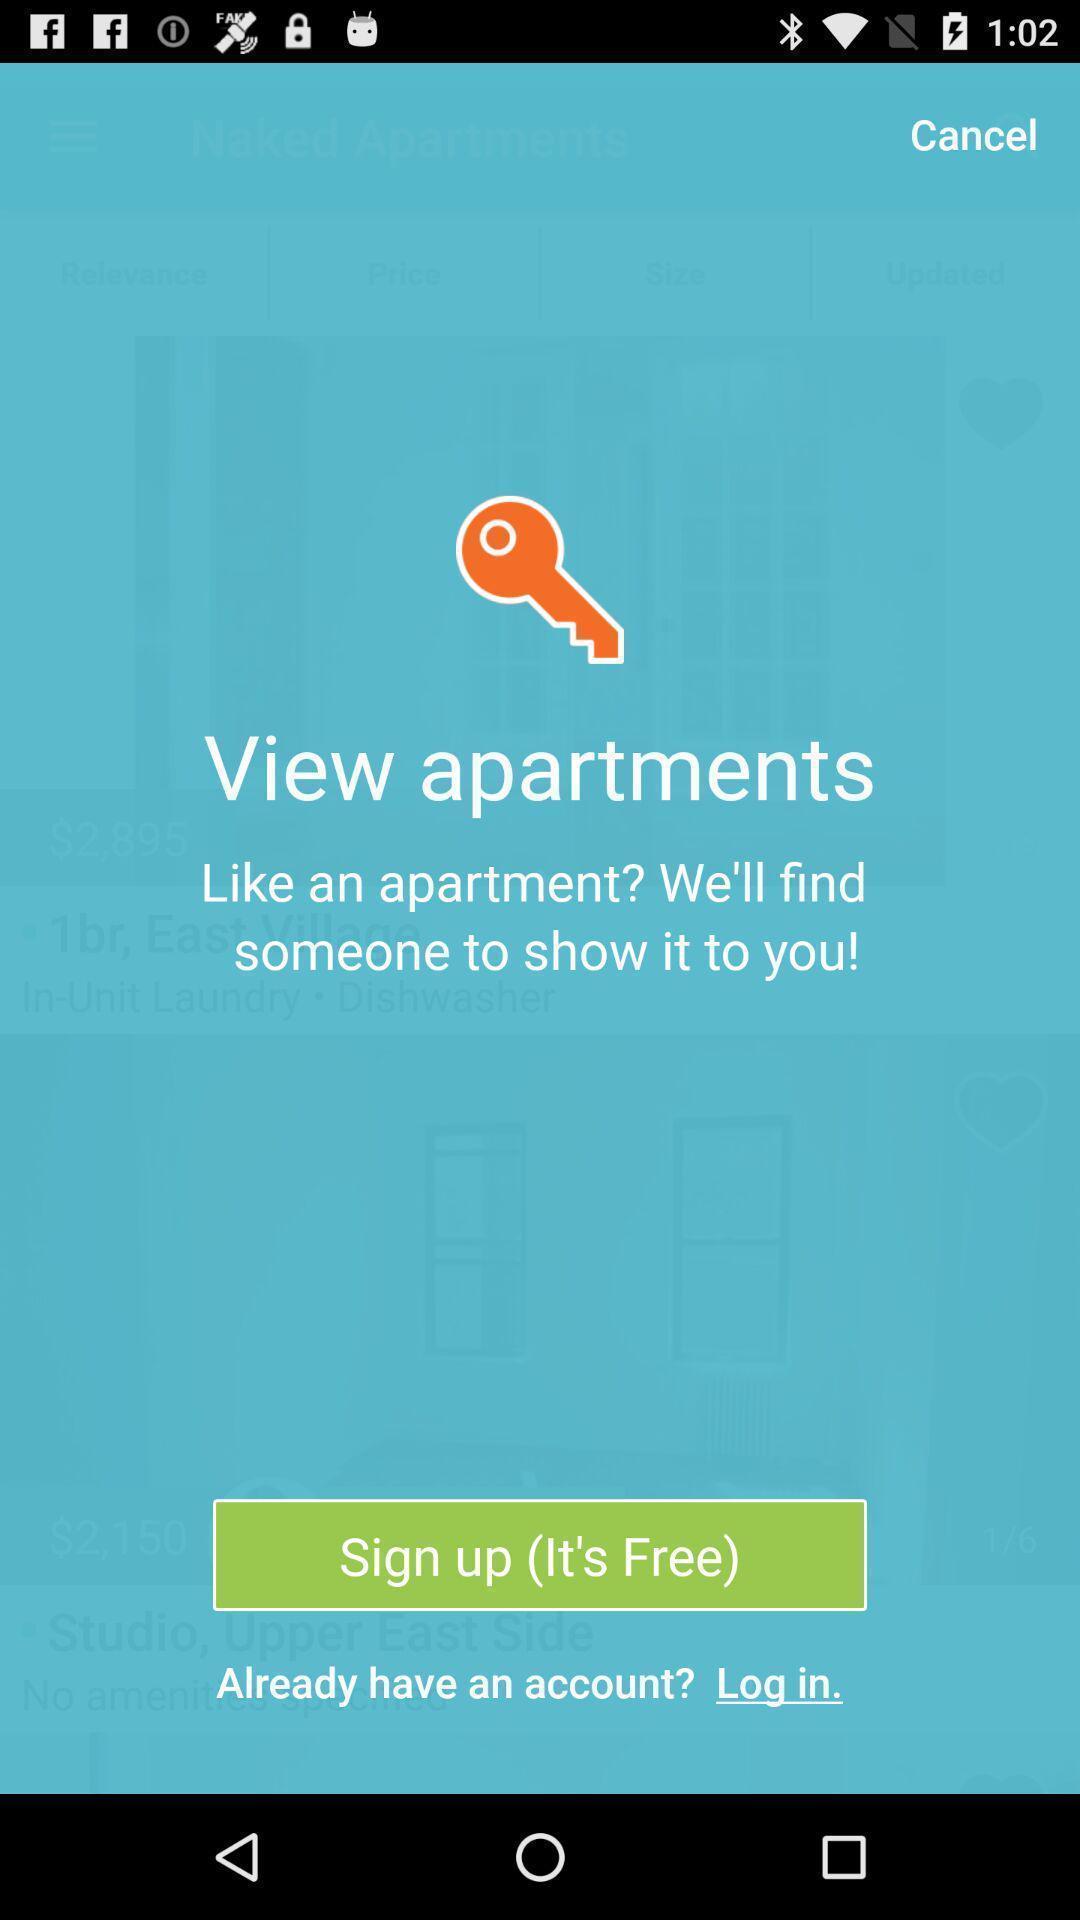What is the overall content of this screenshot? Sign up page for the apartments searching app. 